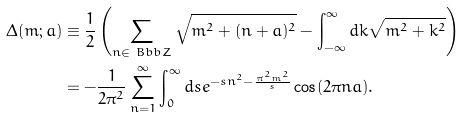<formula> <loc_0><loc_0><loc_500><loc_500>\Delta ( m ; a ) & \equiv \frac { 1 } { 2 } \left ( \sum _ { n \in { \ B b b Z } } \sqrt { m ^ { 2 } + ( n + a ) ^ { 2 } } - \int _ { - \infty } ^ { \infty } d k \sqrt { m ^ { 2 } + k ^ { 2 } } \right ) \\ & = - \frac { 1 } { 2 \pi ^ { 2 } } \sum _ { n = 1 } ^ { \infty } \int _ { 0 } ^ { \infty } d s e ^ { - s n ^ { 2 } - \frac { \pi ^ { 2 } m ^ { 2 } } { s } } \cos ( 2 \pi n a ) .</formula> 